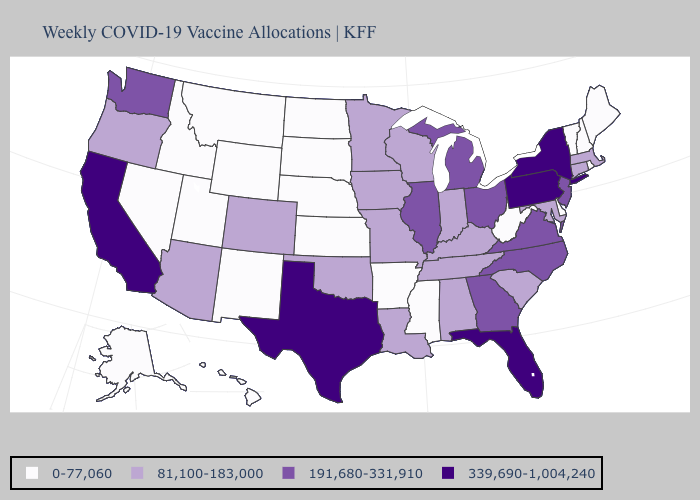Name the states that have a value in the range 0-77,060?
Write a very short answer. Alaska, Arkansas, Delaware, Hawaii, Idaho, Kansas, Maine, Mississippi, Montana, Nebraska, Nevada, New Hampshire, New Mexico, North Dakota, Rhode Island, South Dakota, Utah, Vermont, West Virginia, Wyoming. What is the lowest value in the MidWest?
Keep it brief. 0-77,060. Among the states that border Arkansas , does Texas have the highest value?
Short answer required. Yes. What is the value of Florida?
Be succinct. 339,690-1,004,240. Name the states that have a value in the range 339,690-1,004,240?
Write a very short answer. California, Florida, New York, Pennsylvania, Texas. What is the value of Hawaii?
Write a very short answer. 0-77,060. Which states hav the highest value in the South?
Quick response, please. Florida, Texas. Which states have the highest value in the USA?
Write a very short answer. California, Florida, New York, Pennsylvania, Texas. Among the states that border Nevada , which have the highest value?
Short answer required. California. Does Pennsylvania have the highest value in the USA?
Answer briefly. Yes. Name the states that have a value in the range 0-77,060?
Keep it brief. Alaska, Arkansas, Delaware, Hawaii, Idaho, Kansas, Maine, Mississippi, Montana, Nebraska, Nevada, New Hampshire, New Mexico, North Dakota, Rhode Island, South Dakota, Utah, Vermont, West Virginia, Wyoming. What is the value of Georgia?
Be succinct. 191,680-331,910. What is the value of North Carolina?
Write a very short answer. 191,680-331,910. Does the map have missing data?
Concise answer only. No. Which states have the lowest value in the Northeast?
Concise answer only. Maine, New Hampshire, Rhode Island, Vermont. 